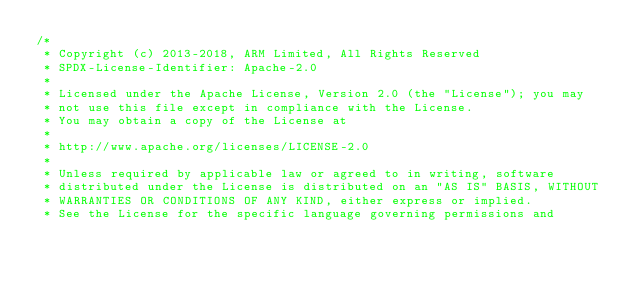Convert code to text. <code><loc_0><loc_0><loc_500><loc_500><_C_>/*
 * Copyright (c) 2013-2018, ARM Limited, All Rights Reserved
 * SPDX-License-Identifier: Apache-2.0
 *
 * Licensed under the Apache License, Version 2.0 (the "License"); you may
 * not use this file except in compliance with the License.
 * You may obtain a copy of the License at
 *
 * http://www.apache.org/licenses/LICENSE-2.0
 *
 * Unless required by applicable law or agreed to in writing, software
 * distributed under the License is distributed on an "AS IS" BASIS, WITHOUT
 * WARRANTIES OR CONDITIONS OF ANY KIND, either express or implied.
 * See the License for the specific language governing permissions and</code> 